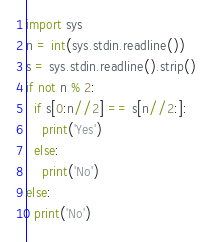<code> <loc_0><loc_0><loc_500><loc_500><_Python_>import sys
n = int(sys.stdin.readline())
s = sys.stdin.readline().strip()
if not n % 2:
  if s[0:n//2] == s[n//2:]:
    print('Yes')
  else:
    print('No')
else:
  print('No')
</code> 